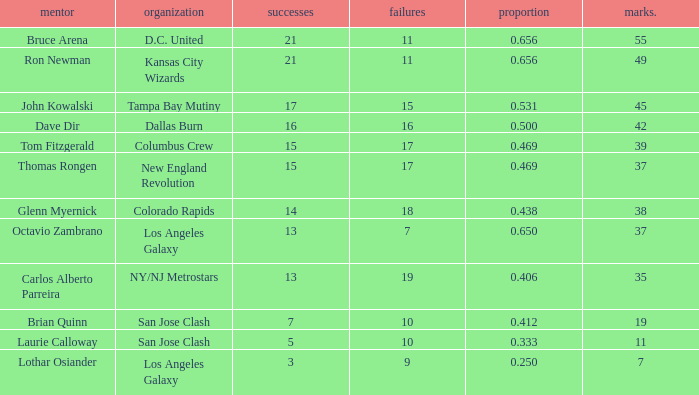What is the highest percent of Bruce Arena when he loses more than 11 games? None. 